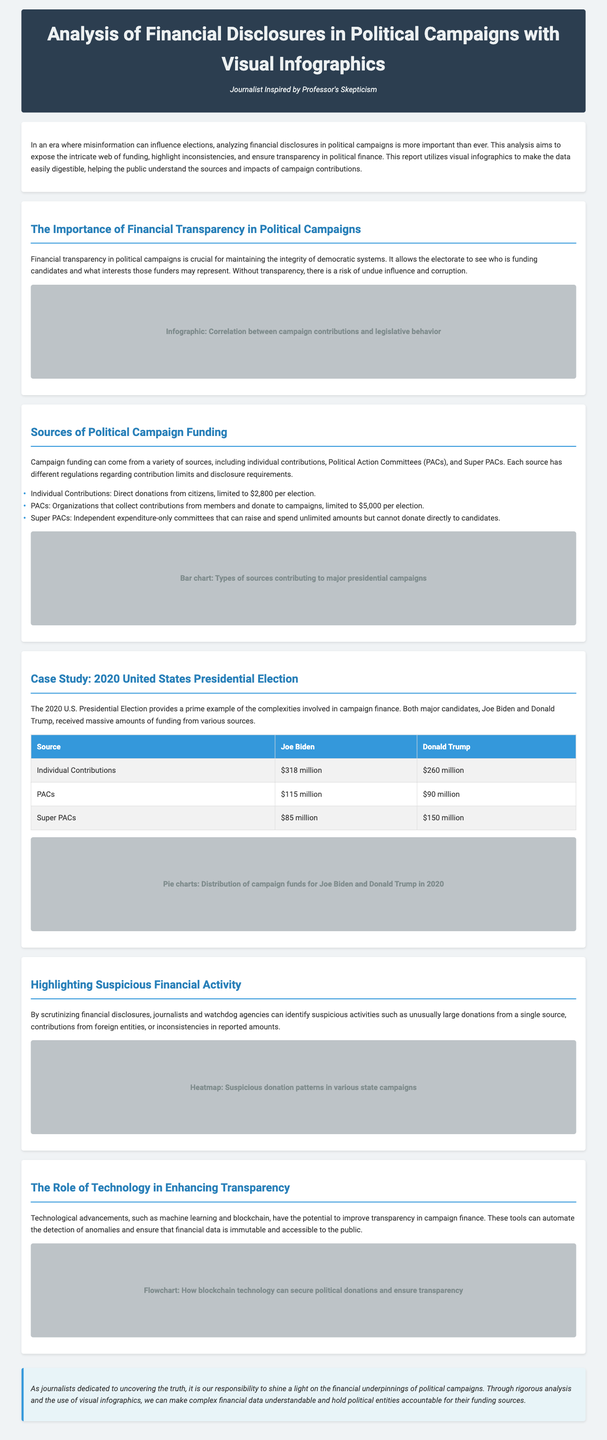what is the total amount of individual contributions for Joe Biden? The total amount of individual contributions for Joe Biden is found in the case study section, which states it is $318 million.
Answer: $318 million what are the three sources of political campaign funding listed? The three sources of political campaign funding mentioned are Individual Contributions, PACs, and Super PACs.
Answer: Individual Contributions, PACs, Super PACs how much did Donald Trump receive from Super PACs? The amount Donald Trump received from Super PACs is stated in the table as $150 million.
Answer: $150 million what relationship does financial transparency have with corruption? The document suggests that without financial transparency, there is a risk of undue influence and corruption in democratic systems.
Answer: Undue influence and corruption what technological tools are mentioned to improve transparency in campaign finance? The document refers to machine learning and blockchain as technological tools that can enhance transparency in campaign finance.
Answer: Machine learning, blockchain how much funding did Joe Biden receive from PACs? The amount received by Joe Biden from PACs is mentioned in the table as $115 million.
Answer: $115 million what visual representation is used to show suspicious donation patterns? The document mentions a heatmap as the visual representation used to highlight suspicious donation patterns in state campaigns.
Answer: Heatmap what is the main goal of analyzing financial disclosures in political campaigns? The primary goal as stated in the introduction is to expose the intricate web of funding and ensure transparency in political finance.
Answer: Ensure transparency in political finance 